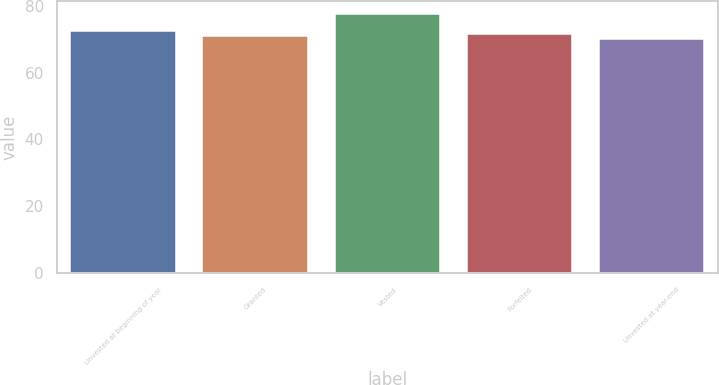<chart> <loc_0><loc_0><loc_500><loc_500><bar_chart><fcel>Unvested at beginning of year<fcel>Granted<fcel>Vested<fcel>Forfeited<fcel>Unvested at year-end<nl><fcel>72.38<fcel>70.88<fcel>77.62<fcel>71.63<fcel>70.13<nl></chart> 